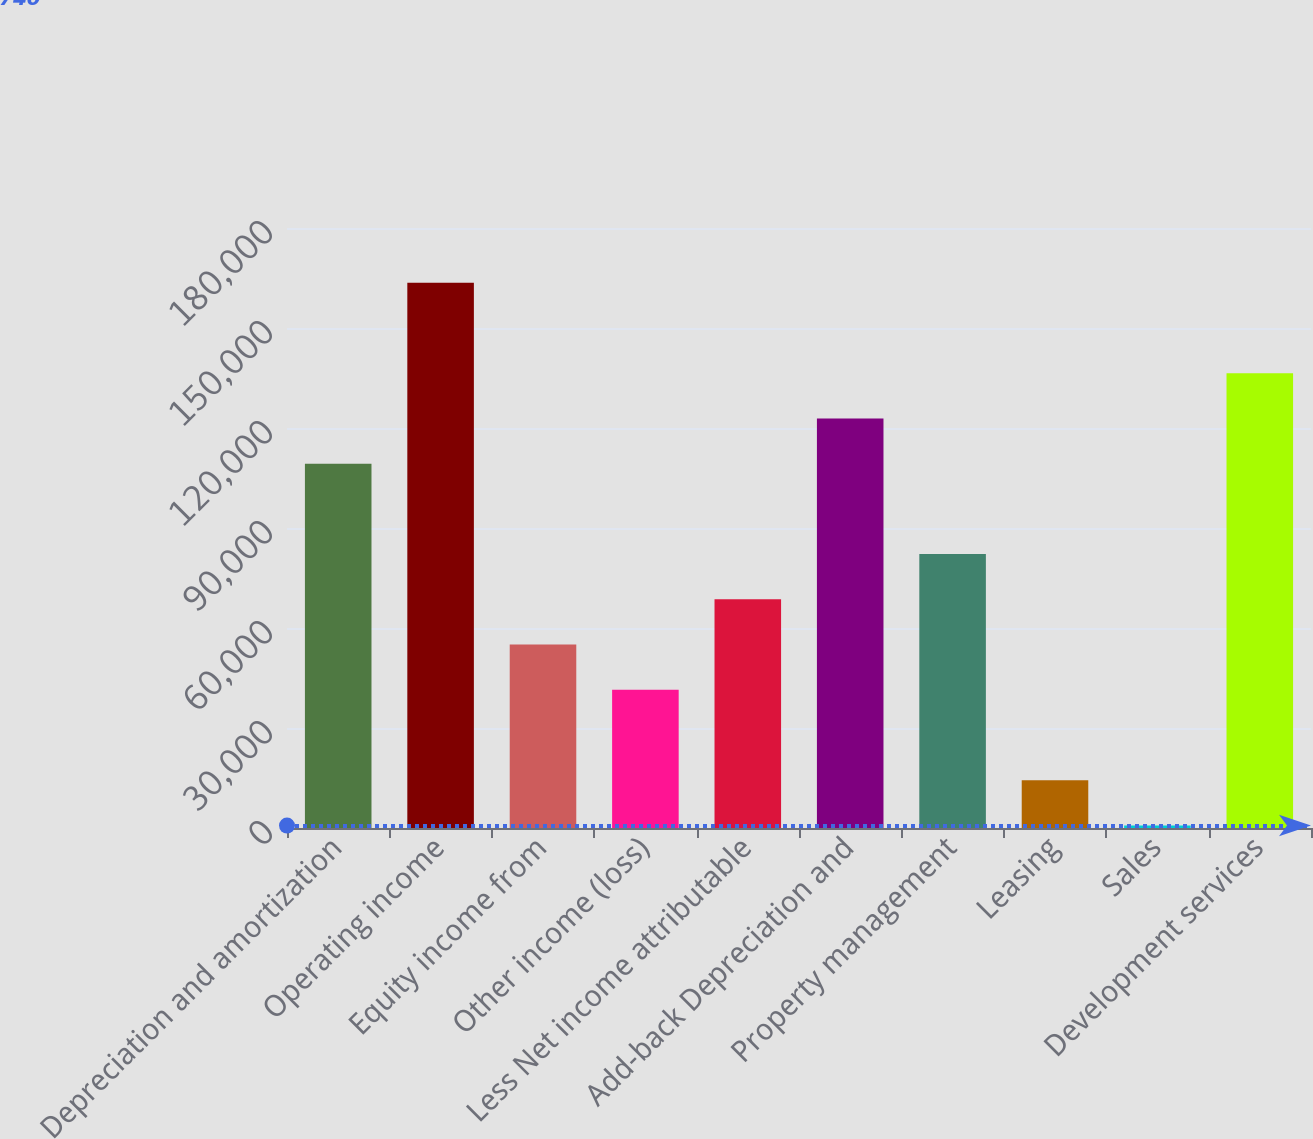Convert chart. <chart><loc_0><loc_0><loc_500><loc_500><bar_chart><fcel>Depreciation and amortization<fcel>Operating income<fcel>Equity income from<fcel>Other income (loss)<fcel>Less Net income attributable<fcel>Add-back Depreciation and<fcel>Property management<fcel>Leasing<fcel>Sales<fcel>Development services<nl><fcel>109306<fcel>163588<fcel>55022.8<fcel>41452.1<fcel>68593.5<fcel>122876<fcel>82164.2<fcel>14310.7<fcel>740<fcel>136447<nl></chart> 